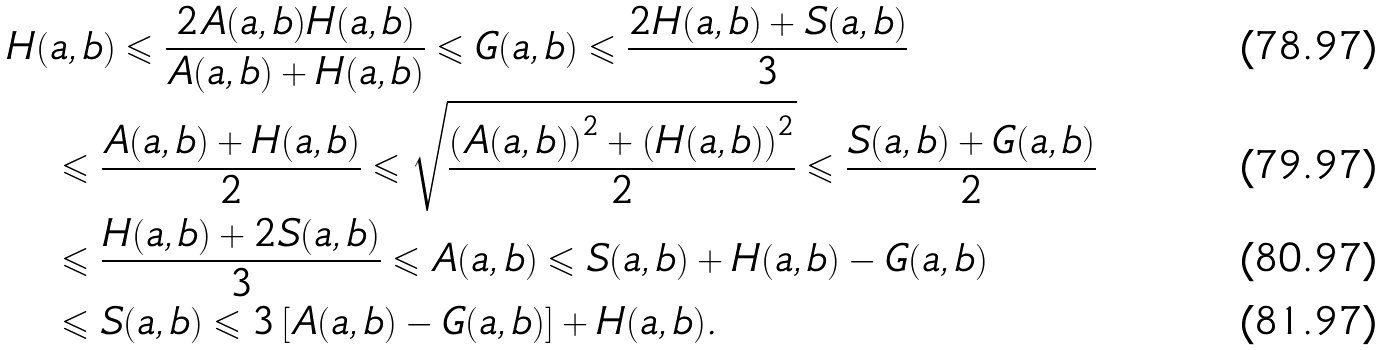Convert formula to latex. <formula><loc_0><loc_0><loc_500><loc_500>& H ( a , b ) \leqslant \frac { 2 A ( a , b ) H ( a , b ) } { A ( a , b ) + H ( a , b ) } \leqslant G ( a , b ) \leqslant \frac { 2 H ( a , b ) + S ( a , b ) } { 3 } \\ & \quad \leqslant \frac { A ( a , b ) + H ( a , b ) } { 2 } \leqslant \sqrt { \frac { \left ( { A ( a , b ) } \right ) ^ { 2 } + \left ( { H ( a , b ) } \right ) ^ { 2 } } { 2 } } \leqslant \frac { S ( a , b ) + G ( a , b ) } { 2 } \\ & \quad \leqslant \frac { H ( a , b ) + 2 S ( a , b ) } { 3 } \leqslant A ( a , b ) \leqslant S ( a , b ) + H ( a , b ) - G ( a , b ) \\ & \quad \leqslant S ( a , b ) \leqslant 3 \left [ { A ( a , b ) - G ( a , b ) } \right ] + H ( a , b ) .</formula> 